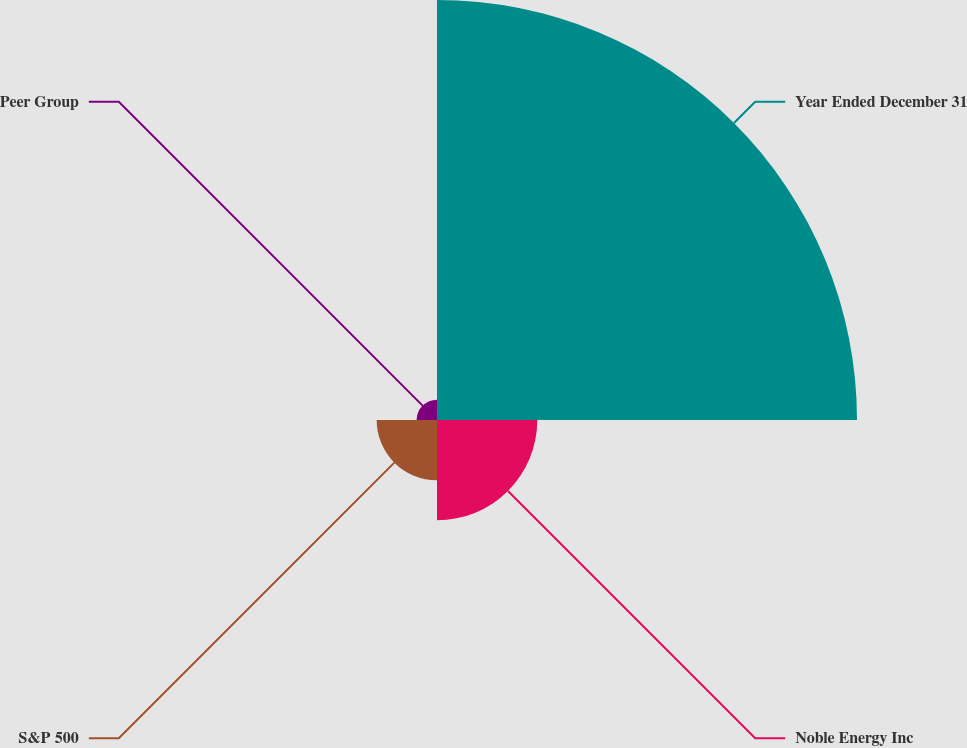<chart> <loc_0><loc_0><loc_500><loc_500><pie_chart><fcel>Year Ended December 31<fcel>Noble Energy Inc<fcel>S&P 500<fcel>Peer Group<nl><fcel>69.89%<fcel>16.69%<fcel>10.04%<fcel>3.39%<nl></chart> 